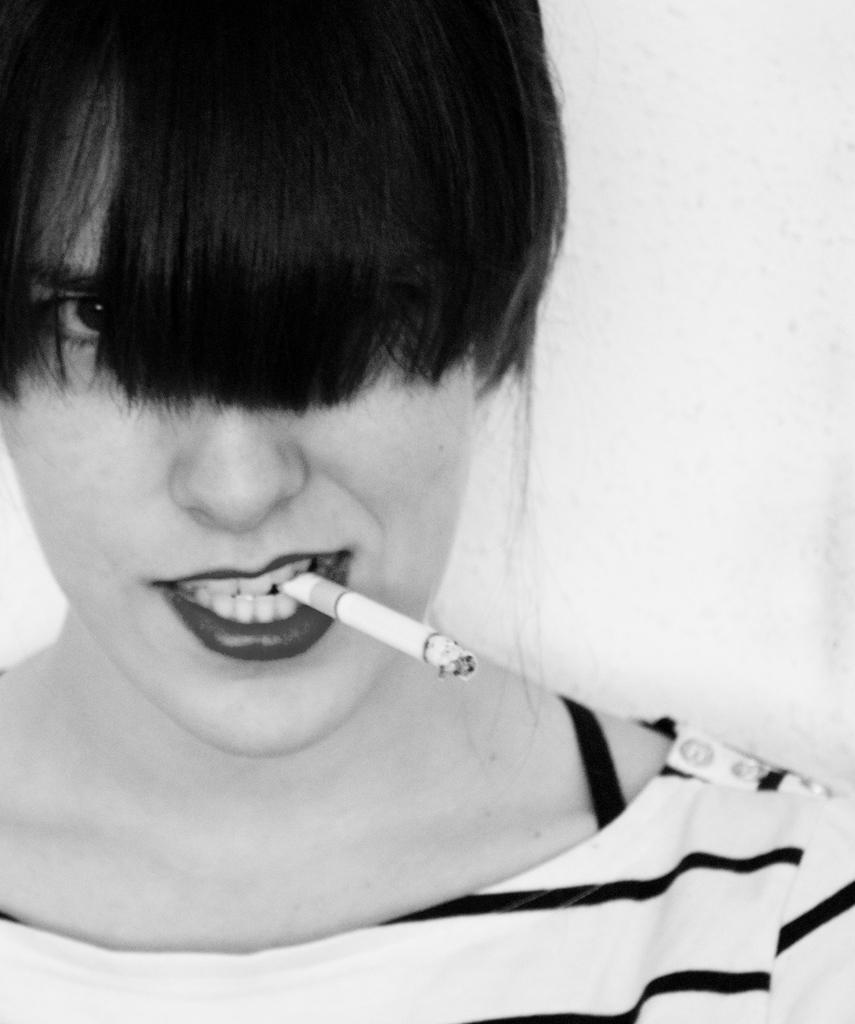Who is the main subject in the image? There is a lady in the image. Can you describe the lady's appearance? The lady's eyes are covered by her hair. What is the lady holding in her mouth? The lady has a lit cigarette in her mouth. What type of rifle is the lady holding in the image? There is no rifle present in the image; the lady has a lit cigarette in her mouth. How do the dinosaurs show respect to the lady in the image? There are no dinosaurs present in the image, so they cannot show respect to the lady. 